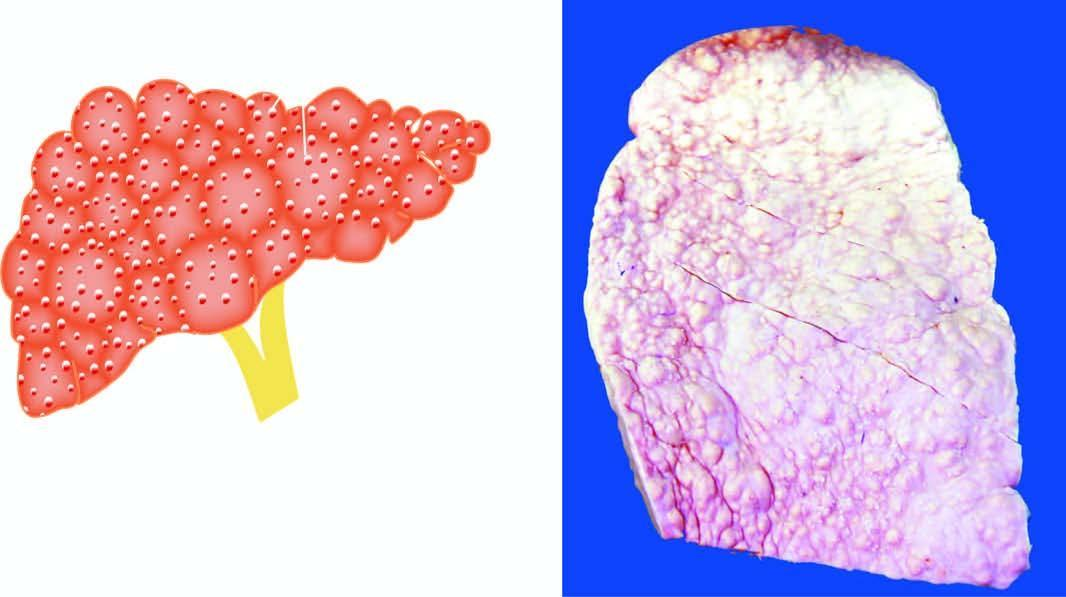s bdominal fat aspirate stained with congo red small, distorted and irregularly scarred?
Answer the question using a single word or phrase. No 